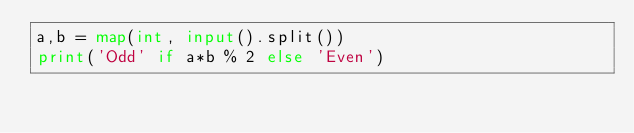Convert code to text. <code><loc_0><loc_0><loc_500><loc_500><_Python_>a,b = map(int, input().split())
print('Odd' if a*b % 2 else 'Even')</code> 